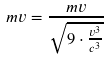<formula> <loc_0><loc_0><loc_500><loc_500>m v = \frac { m v } { \sqrt { 9 \cdot \frac { v ^ { 3 } } { c ^ { 3 } } } }</formula> 